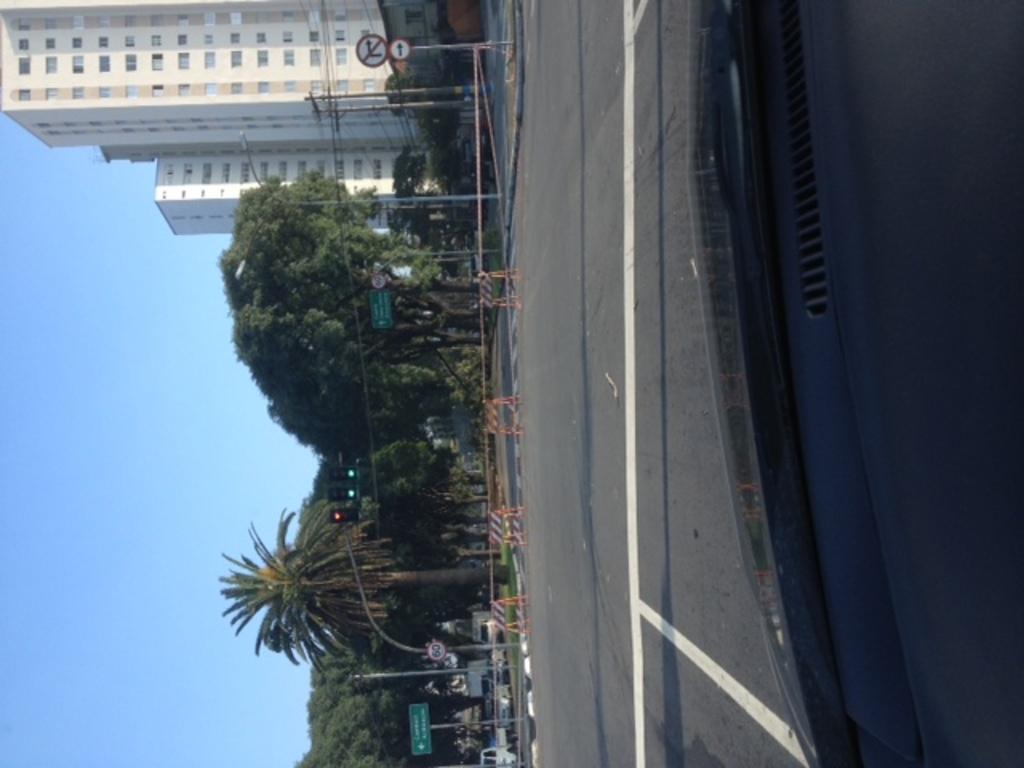Please provide a concise description of this image. In this image we can see there are trees, buildings, poles, street lights, sign board and there are barricades and vehicles on the road. At the top there is the sky. 